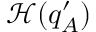Convert formula to latex. <formula><loc_0><loc_0><loc_500><loc_500>\mathcal { H } ( q _ { A } ^ { \prime } )</formula> 